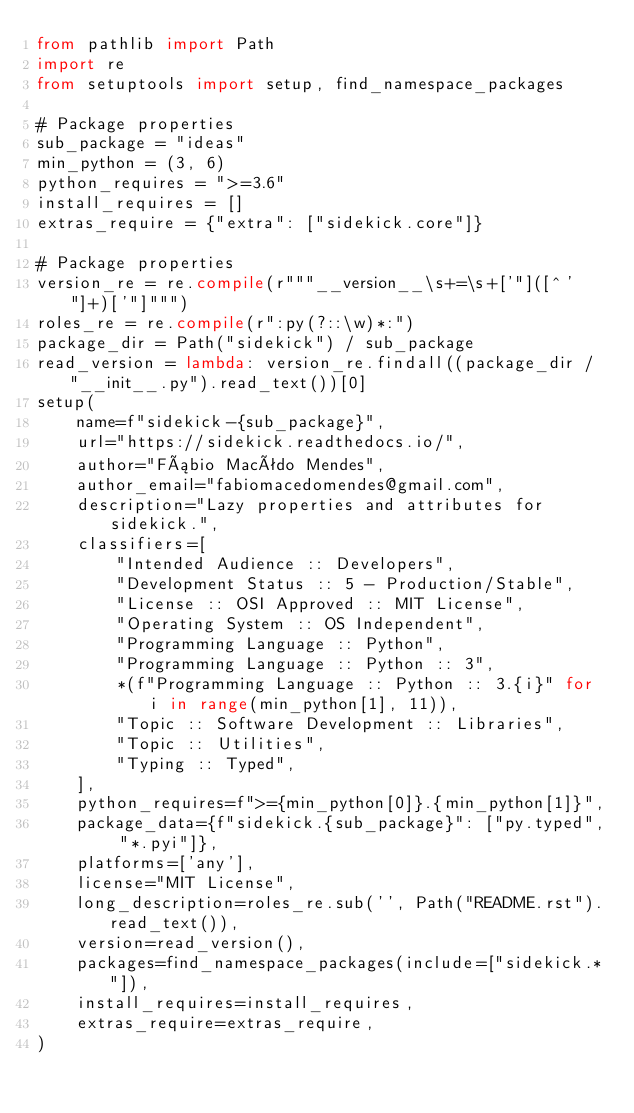Convert code to text. <code><loc_0><loc_0><loc_500><loc_500><_Python_>from pathlib import Path
import re
from setuptools import setup, find_namespace_packages

# Package properties
sub_package = "ideas"
min_python = (3, 6)
python_requires = ">=3.6"
install_requires = []
extras_require = {"extra": ["sidekick.core"]}

# Package properties
version_re = re.compile(r"""__version__\s+=\s+['"]([^'"]+)['"]""")
roles_re = re.compile(r":py(?::\w)*:")
package_dir = Path("sidekick") / sub_package
read_version = lambda: version_re.findall((package_dir / "__init__.py").read_text())[0]
setup(
    name=f"sidekick-{sub_package}",
    url="https://sidekick.readthedocs.io/",
    author="Fábio Macêdo Mendes",
    author_email="fabiomacedomendes@gmail.com",
    description="Lazy properties and attributes for sidekick.",
    classifiers=[
        "Intended Audience :: Developers",
        "Development Status :: 5 - Production/Stable",
        "License :: OSI Approved :: MIT License",
        "Operating System :: OS Independent",
        "Programming Language :: Python",
        "Programming Language :: Python :: 3",
        *(f"Programming Language :: Python :: 3.{i}" for i in range(min_python[1], 11)),
        "Topic :: Software Development :: Libraries",
        "Topic :: Utilities",
        "Typing :: Typed",
    ],
    python_requires=f">={min_python[0]}.{min_python[1]}",
    package_data={f"sidekick.{sub_package}": ["py.typed", "*.pyi"]},
    platforms=['any'],
    license="MIT License",
    long_description=roles_re.sub('', Path("README.rst").read_text()),
    version=read_version(),
    packages=find_namespace_packages(include=["sidekick.*"]),
    install_requires=install_requires,
    extras_require=extras_require,
)
</code> 